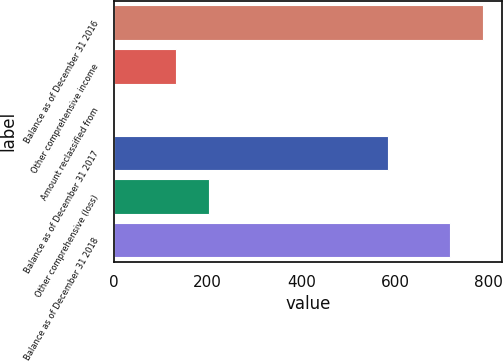Convert chart to OTSL. <chart><loc_0><loc_0><loc_500><loc_500><bar_chart><fcel>Balance as of December 31 2016<fcel>Other comprehensive income<fcel>Amount reclassified from<fcel>Balance as of December 31 2017<fcel>Other comprehensive (loss)<fcel>Balance as of December 31 2018<nl><fcel>788.15<fcel>132.2<fcel>1.1<fcel>585.3<fcel>203.95<fcel>716.4<nl></chart> 